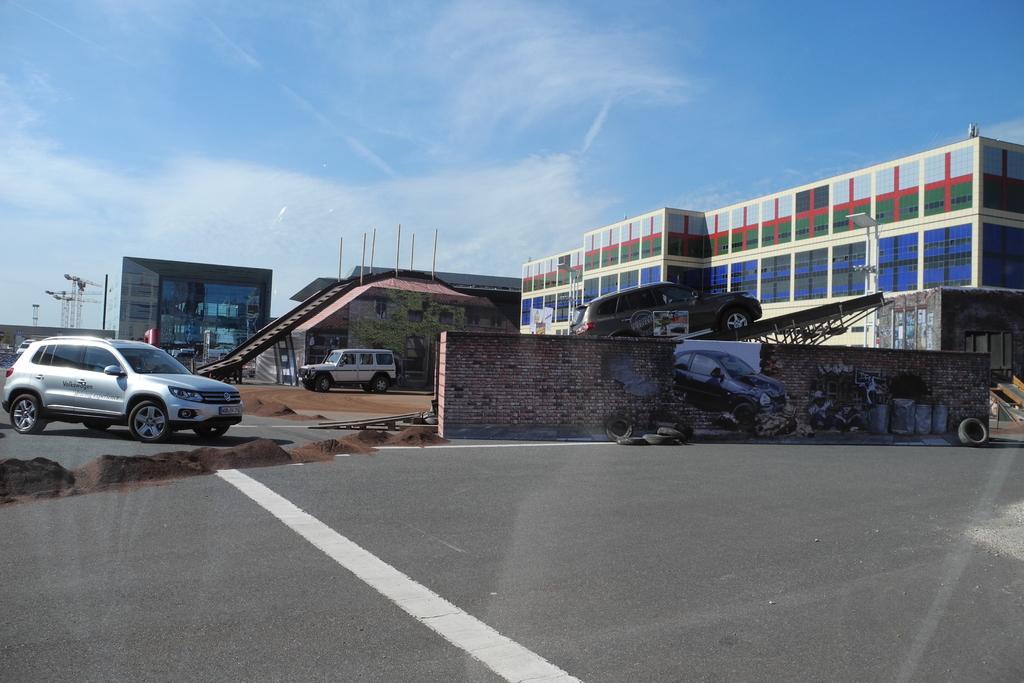How would you summarize this image in a sentence or two? This is the picture of a building. In this image there are buildings and there are vehicles at the back. On the right side of the image there is a vehicle on the ramp. On the left side of the image there are cranes. In the foreground there is a road and there is a painting of a vehicle on the wall and there are tyres on the road. At the top there is sky and there are clouds. At the bottom there is a road. 